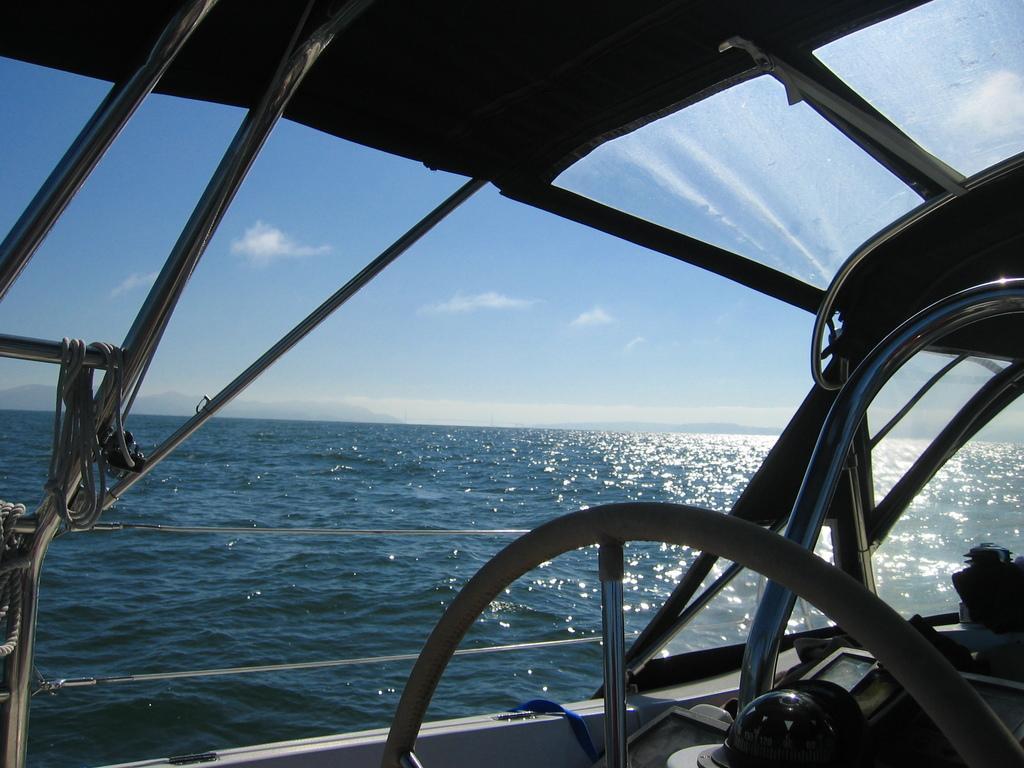Describe this image in one or two sentences. We can see ship and water. We can see sky. 